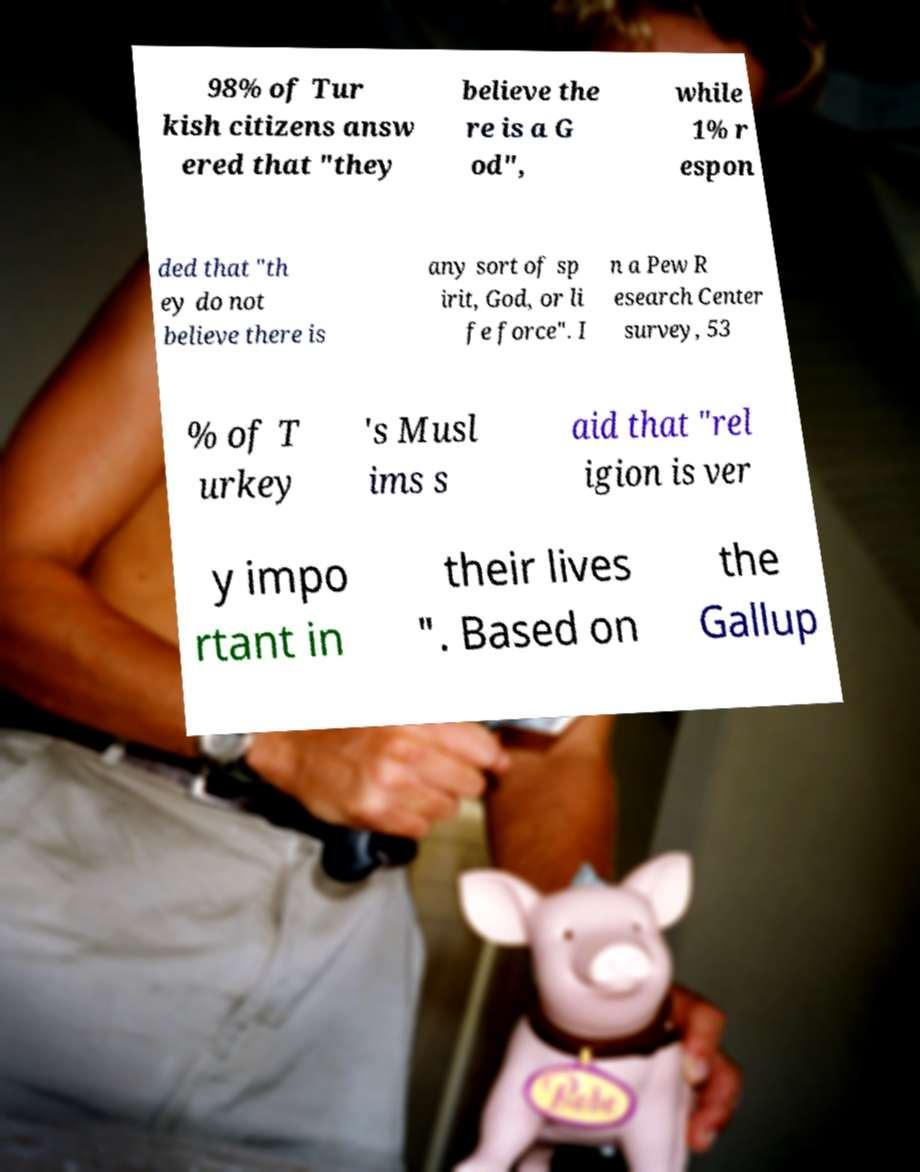Can you read and provide the text displayed in the image?This photo seems to have some interesting text. Can you extract and type it out for me? 98% of Tur kish citizens answ ered that "they believe the re is a G od", while 1% r espon ded that "th ey do not believe there is any sort of sp irit, God, or li fe force". I n a Pew R esearch Center survey, 53 % of T urkey 's Musl ims s aid that "rel igion is ver y impo rtant in their lives ". Based on the Gallup 